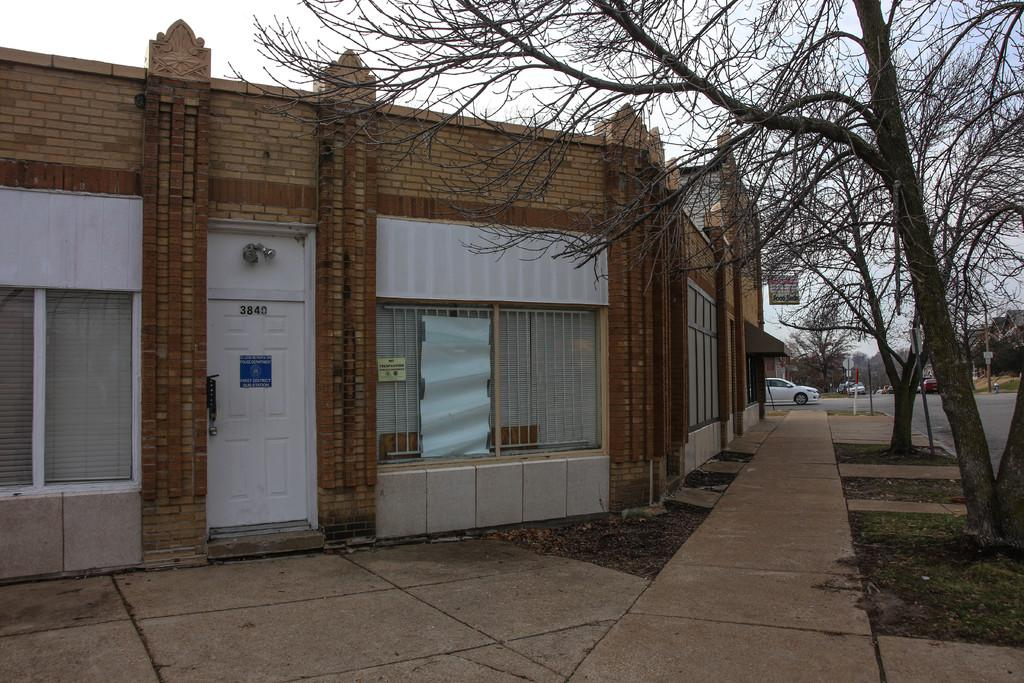What can be seen on the road in the image? There are vehicles on the road in the image. What type of vegetation is present in the image? There are trees and grass in the image. What type of path is visible in the image? There is a footpath in the image. What type of structure is present in the image? There is a building with windows in the image. What is the entrance to the building like? There is a door in the building. What additional feature can be seen in the image? There is a banner in the image. What is visible in the background of the image? The sky is visible in the background of the image. Can you tell me how many governors are walking near the lake in the image? There is no lake or governor present in the image. What type of creature is swimming in the rainstorm in the image? There is no rainstorm or creature swimming in the image. 